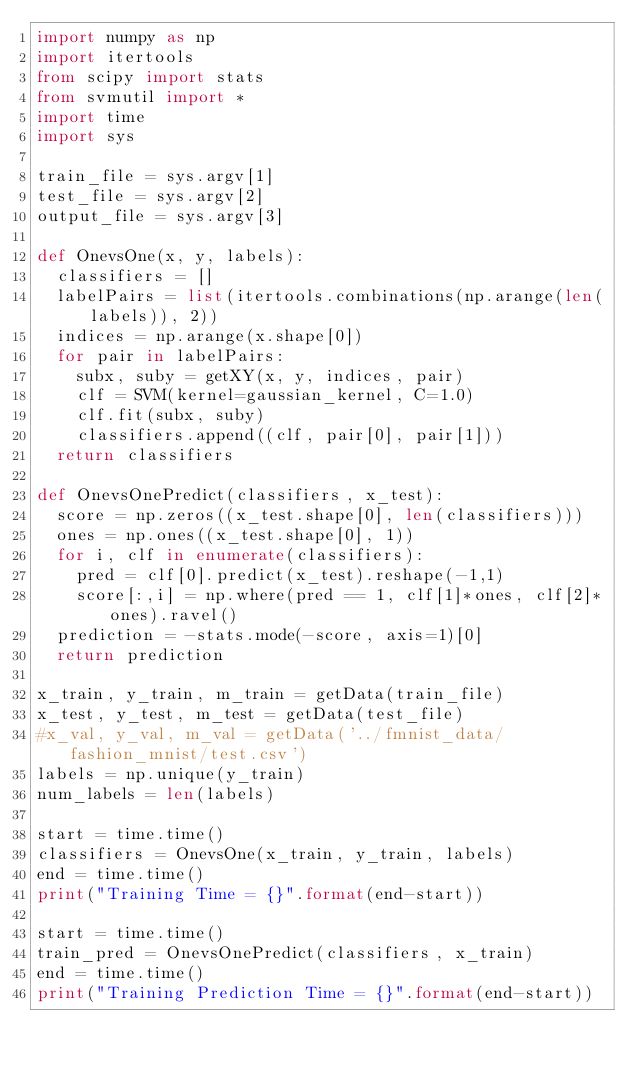<code> <loc_0><loc_0><loc_500><loc_500><_Python_>import numpy as np
import itertools
from scipy import stats
from svmutil import *
import time
import sys

train_file = sys.argv[1]
test_file = sys.argv[2]
output_file = sys.argv[3]

def OnevsOne(x, y, labels):
	classifiers = []
	labelPairs = list(itertools.combinations(np.arange(len(labels)), 2))
	indices = np.arange(x.shape[0])
	for pair in labelPairs:
		subx, suby = getXY(x, y, indices, pair)
		clf = SVM(kernel=gaussian_kernel, C=1.0)
		clf.fit(subx, suby)
		classifiers.append((clf, pair[0], pair[1]))
	return classifiers

def OnevsOnePredict(classifiers, x_test):
	score = np.zeros((x_test.shape[0], len(classifiers)))
	ones = np.ones((x_test.shape[0], 1))
	for i, clf in enumerate(classifiers):
		pred = clf[0].predict(x_test).reshape(-1,1)
		score[:,i] = np.where(pred == 1, clf[1]*ones, clf[2]*ones).ravel()
	prediction = -stats.mode(-score, axis=1)[0]
	return prediction

x_train, y_train, m_train = getData(train_file)
x_test, y_test, m_test = getData(test_file)
#x_val, y_val, m_val = getData('../fmnist_data/fashion_mnist/test.csv')
labels = np.unique(y_train)
num_labels = len(labels)

start = time.time()
classifiers = OnevsOne(x_train, y_train, labels)
end = time.time()
print("Training Time = {}".format(end-start))

start = time.time()
train_pred = OnevsOnePredict(classifiers, x_train)
end = time.time()
print("Training Prediction Time = {}".format(end-start))</code> 